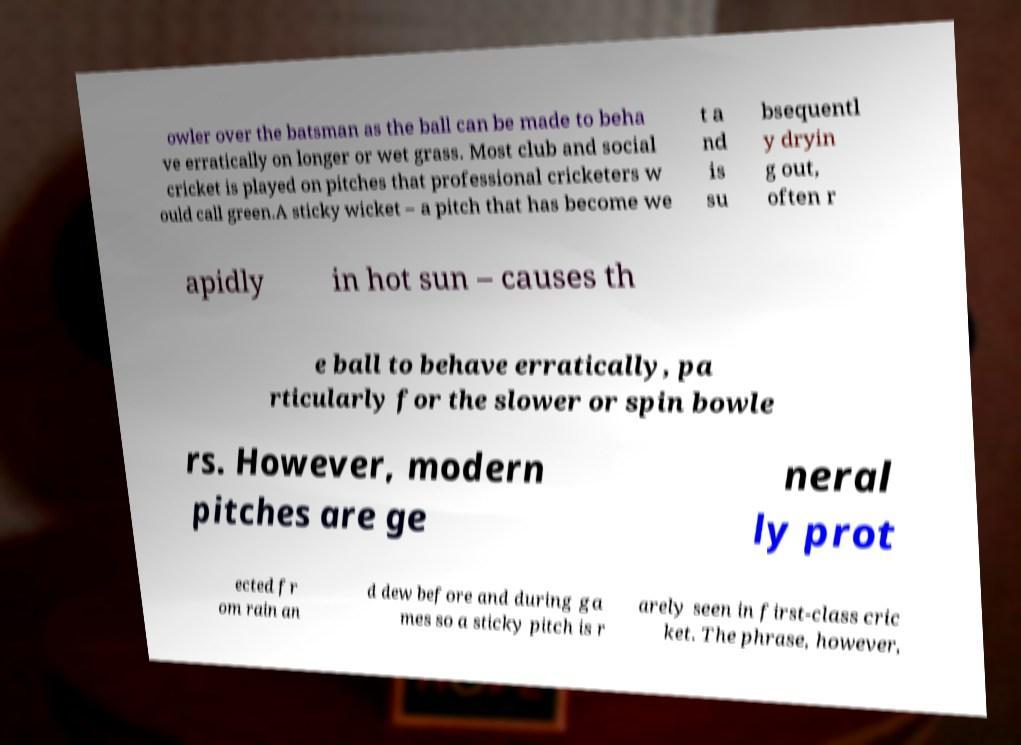Please identify and transcribe the text found in this image. owler over the batsman as the ball can be made to beha ve erratically on longer or wet grass. Most club and social cricket is played on pitches that professional cricketers w ould call green.A sticky wicket – a pitch that has become we t a nd is su bsequentl y dryin g out, often r apidly in hot sun – causes th e ball to behave erratically, pa rticularly for the slower or spin bowle rs. However, modern pitches are ge neral ly prot ected fr om rain an d dew before and during ga mes so a sticky pitch is r arely seen in first-class cric ket. The phrase, however, 